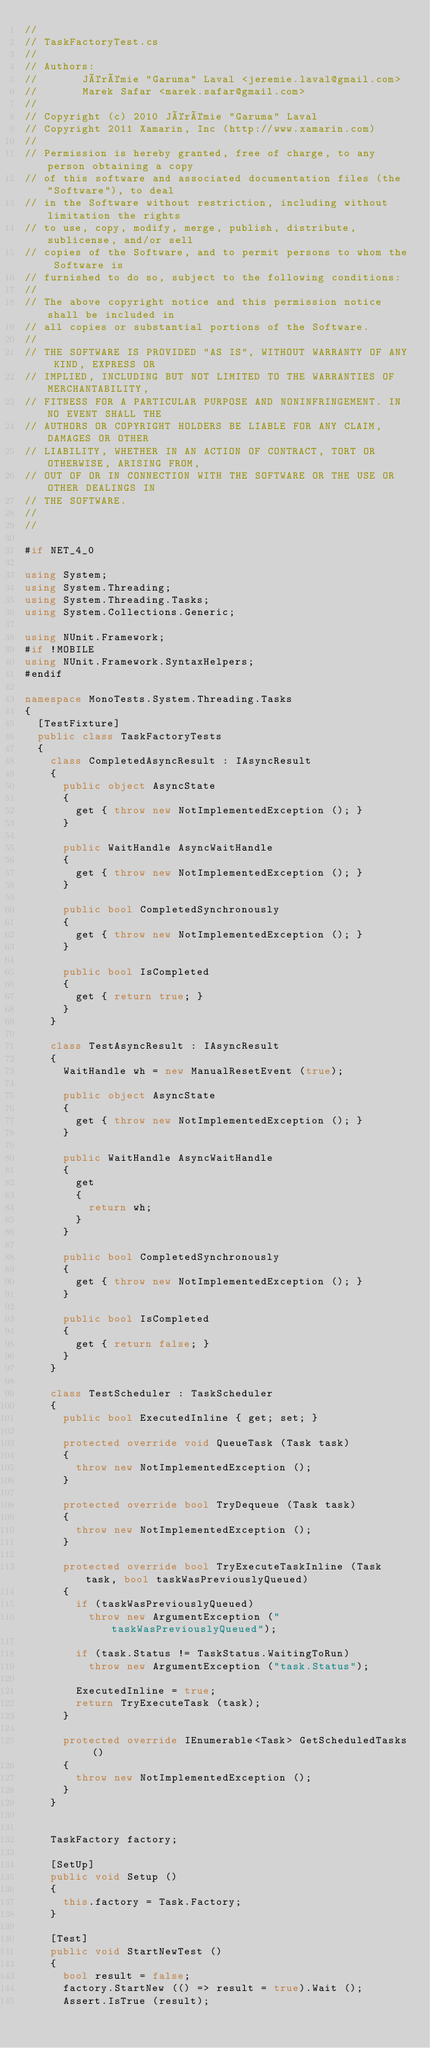<code> <loc_0><loc_0><loc_500><loc_500><_C#_>//
// TaskFactoryTest.cs
//
// Authors:
//       Jérémie "Garuma" Laval <jeremie.laval@gmail.com>
//       Marek Safar <marek.safar@gmail.com>
// 
// Copyright (c) 2010 Jérémie "Garuma" Laval
// Copyright 2011 Xamarin, Inc (http://www.xamarin.com)
//
// Permission is hereby granted, free of charge, to any person obtaining a copy
// of this software and associated documentation files (the "Software"), to deal
// in the Software without restriction, including without limitation the rights
// to use, copy, modify, merge, publish, distribute, sublicense, and/or sell
// copies of the Software, and to permit persons to whom the Software is
// furnished to do so, subject to the following conditions:
//
// The above copyright notice and this permission notice shall be included in
// all copies or substantial portions of the Software.
//
// THE SOFTWARE IS PROVIDED "AS IS", WITHOUT WARRANTY OF ANY KIND, EXPRESS OR
// IMPLIED, INCLUDING BUT NOT LIMITED TO THE WARRANTIES OF MERCHANTABILITY,
// FITNESS FOR A PARTICULAR PURPOSE AND NONINFRINGEMENT. IN NO EVENT SHALL THE
// AUTHORS OR COPYRIGHT HOLDERS BE LIABLE FOR ANY CLAIM, DAMAGES OR OTHER
// LIABILITY, WHETHER IN AN ACTION OF CONTRACT, TORT OR OTHERWISE, ARISING FROM,
// OUT OF OR IN CONNECTION WITH THE SOFTWARE OR THE USE OR OTHER DEALINGS IN
// THE SOFTWARE.
//
//

#if NET_4_0

using System;
using System.Threading;
using System.Threading.Tasks;
using System.Collections.Generic;

using NUnit.Framework;
#if !MOBILE
using NUnit.Framework.SyntaxHelpers;
#endif

namespace MonoTests.System.Threading.Tasks
{
	[TestFixture]
	public class TaskFactoryTests
	{
		class CompletedAsyncResult : IAsyncResult
		{
			public object AsyncState
			{
				get { throw new NotImplementedException (); }
			}

			public WaitHandle AsyncWaitHandle
			{
				get { throw new NotImplementedException (); }
			}

			public bool CompletedSynchronously
			{
				get { throw new NotImplementedException (); }
			}

			public bool IsCompleted
			{
				get { return true; }
			}
		}

		class TestAsyncResult : IAsyncResult
		{
			WaitHandle wh = new ManualResetEvent (true);

			public object AsyncState
			{
				get { throw new NotImplementedException (); }
			}

			public WaitHandle AsyncWaitHandle
			{
				get
				{
					return wh;
				}
			}

			public bool CompletedSynchronously
			{
				get { throw new NotImplementedException (); }
			}

			public bool IsCompleted
			{
				get { return false; }
			}
		}

		class TestScheduler : TaskScheduler
		{
			public bool ExecutedInline { get; set; }

			protected override void QueueTask (Task task)
			{
				throw new NotImplementedException ();
			}

			protected override bool TryDequeue (Task task)
			{
				throw new NotImplementedException ();
			}

			protected override bool TryExecuteTaskInline (Task task, bool taskWasPreviouslyQueued)
			{
				if (taskWasPreviouslyQueued)
					throw new ArgumentException ("taskWasPreviouslyQueued");

				if (task.Status != TaskStatus.WaitingToRun)
					throw new ArgumentException ("task.Status");

				ExecutedInline = true;
				return TryExecuteTask (task);
			}

			protected override IEnumerable<Task> GetScheduledTasks ()
			{
				throw new NotImplementedException ();
			}
		}


		TaskFactory factory;

		[SetUp]
		public void Setup ()
		{
			this.factory = Task.Factory;
		}

		[Test]
		public void StartNewTest ()
		{
			bool result = false;
			factory.StartNew (() => result = true).Wait ();
			Assert.IsTrue (result);</code> 